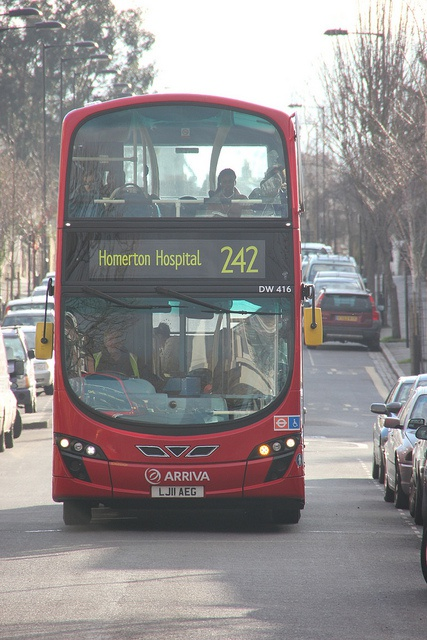Describe the objects in this image and their specific colors. I can see bus in darkgray, gray, and brown tones, car in darkgray, gray, brown, and lavender tones, car in darkgray, gray, black, and lightgray tones, car in darkgray, gray, white, and lightblue tones, and people in darkgray, gray, brown, and olive tones in this image. 